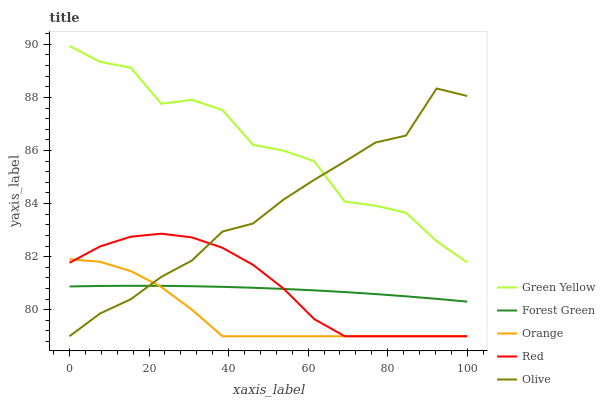Does Orange have the minimum area under the curve?
Answer yes or no. Yes. Does Green Yellow have the maximum area under the curve?
Answer yes or no. Yes. Does Olive have the minimum area under the curve?
Answer yes or no. No. Does Olive have the maximum area under the curve?
Answer yes or no. No. Is Forest Green the smoothest?
Answer yes or no. Yes. Is Green Yellow the roughest?
Answer yes or no. Yes. Is Olive the smoothest?
Answer yes or no. No. Is Olive the roughest?
Answer yes or no. No. Does Forest Green have the lowest value?
Answer yes or no. No. Does Olive have the highest value?
Answer yes or no. No. Is Red less than Green Yellow?
Answer yes or no. Yes. Is Green Yellow greater than Orange?
Answer yes or no. Yes. Does Red intersect Green Yellow?
Answer yes or no. No. 